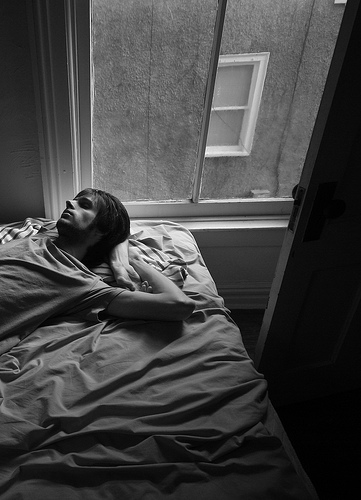Can you give a detailed description of how the person on the bed might be feeling? The person lying on the bed seems to be in a state of quiet contemplation. With their body relaxed and eyes gazing upwards, they might be reflecting on their thoughts and emotions, possibly savoring the serene moment. The open window may allow a gentle breeze to brush against their skin, adding to the sense of calmness and tranquility. Their position and expression suggest that they are at peace, enjoying a rare moment of solitude and introspection. 